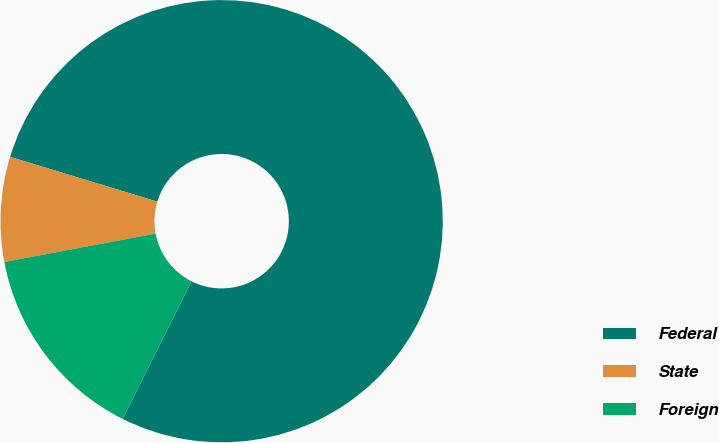<chart> <loc_0><loc_0><loc_500><loc_500><pie_chart><fcel>Federal<fcel>State<fcel>Foreign<nl><fcel>77.7%<fcel>7.65%<fcel>14.65%<nl></chart> 